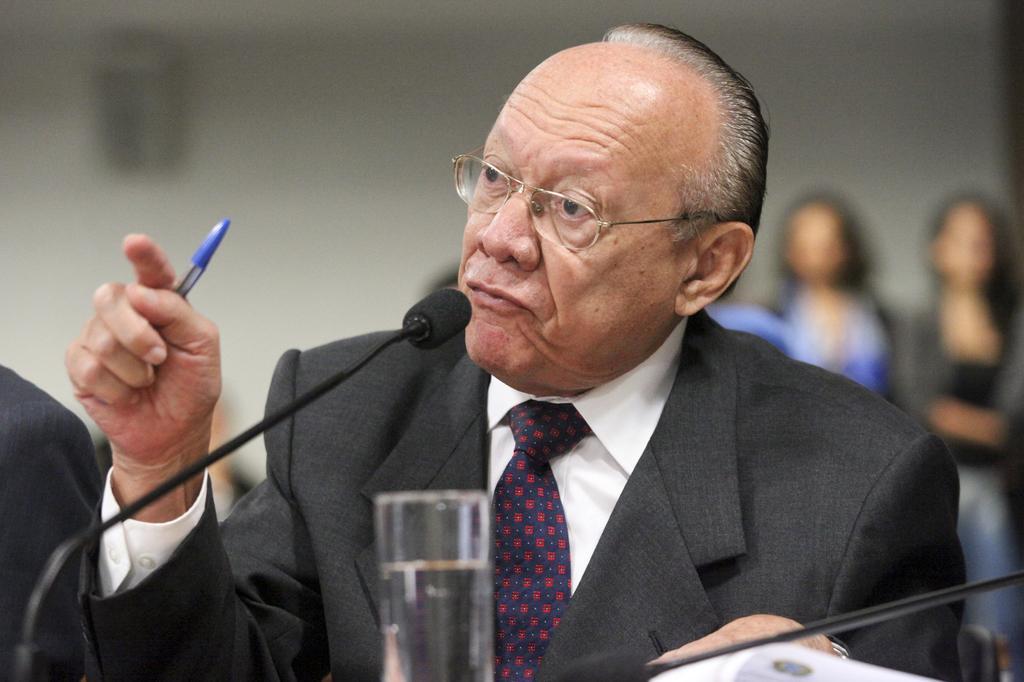Could you give a brief overview of what you see in this image? In this image I can see person holding a pen and in front of person I can see a mike, glass contain a water visible in the foreground, in the background I can see the wall, in front of the wall I can see two persons on the right side. 